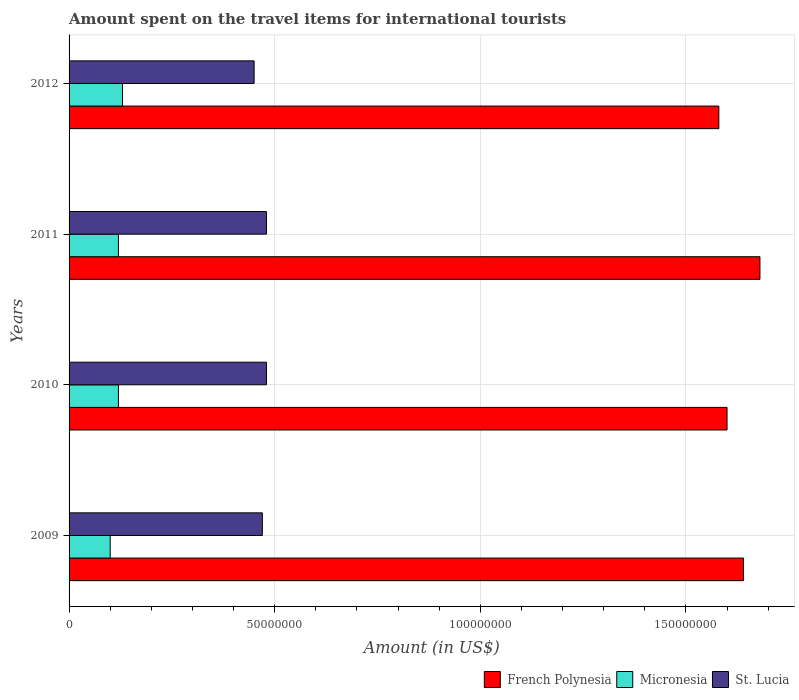How many bars are there on the 4th tick from the top?
Your answer should be compact. 3. In how many cases, is the number of bars for a given year not equal to the number of legend labels?
Offer a terse response. 0. What is the amount spent on the travel items for international tourists in St. Lucia in 2010?
Your response must be concise. 4.80e+07. Across all years, what is the maximum amount spent on the travel items for international tourists in Micronesia?
Give a very brief answer. 1.30e+07. Across all years, what is the minimum amount spent on the travel items for international tourists in St. Lucia?
Keep it short and to the point. 4.50e+07. In which year was the amount spent on the travel items for international tourists in French Polynesia minimum?
Keep it short and to the point. 2012. What is the total amount spent on the travel items for international tourists in St. Lucia in the graph?
Offer a very short reply. 1.88e+08. What is the difference between the amount spent on the travel items for international tourists in St. Lucia in 2010 and that in 2011?
Your answer should be very brief. 0. What is the difference between the amount spent on the travel items for international tourists in French Polynesia in 2010 and the amount spent on the travel items for international tourists in Micronesia in 2009?
Provide a succinct answer. 1.50e+08. What is the average amount spent on the travel items for international tourists in Micronesia per year?
Offer a terse response. 1.18e+07. In the year 2011, what is the difference between the amount spent on the travel items for international tourists in French Polynesia and amount spent on the travel items for international tourists in Micronesia?
Provide a short and direct response. 1.56e+08. What is the ratio of the amount spent on the travel items for international tourists in French Polynesia in 2010 to that in 2012?
Offer a terse response. 1.01. Is the sum of the amount spent on the travel items for international tourists in St. Lucia in 2010 and 2011 greater than the maximum amount spent on the travel items for international tourists in French Polynesia across all years?
Offer a terse response. No. What does the 2nd bar from the top in 2012 represents?
Give a very brief answer. Micronesia. What does the 1st bar from the bottom in 2009 represents?
Ensure brevity in your answer.  French Polynesia. Is it the case that in every year, the sum of the amount spent on the travel items for international tourists in St. Lucia and amount spent on the travel items for international tourists in Micronesia is greater than the amount spent on the travel items for international tourists in French Polynesia?
Make the answer very short. No. How many bars are there?
Keep it short and to the point. 12. Are all the bars in the graph horizontal?
Give a very brief answer. Yes. How many years are there in the graph?
Offer a very short reply. 4. What is the difference between two consecutive major ticks on the X-axis?
Provide a succinct answer. 5.00e+07. Are the values on the major ticks of X-axis written in scientific E-notation?
Your answer should be compact. No. Where does the legend appear in the graph?
Ensure brevity in your answer.  Bottom right. How are the legend labels stacked?
Keep it short and to the point. Horizontal. What is the title of the graph?
Give a very brief answer. Amount spent on the travel items for international tourists. Does "Lower middle income" appear as one of the legend labels in the graph?
Keep it short and to the point. No. What is the label or title of the Y-axis?
Ensure brevity in your answer.  Years. What is the Amount (in US$) in French Polynesia in 2009?
Provide a short and direct response. 1.64e+08. What is the Amount (in US$) in Micronesia in 2009?
Your answer should be compact. 1.00e+07. What is the Amount (in US$) of St. Lucia in 2009?
Make the answer very short. 4.70e+07. What is the Amount (in US$) in French Polynesia in 2010?
Your answer should be very brief. 1.60e+08. What is the Amount (in US$) in Micronesia in 2010?
Keep it short and to the point. 1.20e+07. What is the Amount (in US$) in St. Lucia in 2010?
Provide a short and direct response. 4.80e+07. What is the Amount (in US$) in French Polynesia in 2011?
Ensure brevity in your answer.  1.68e+08. What is the Amount (in US$) of Micronesia in 2011?
Offer a terse response. 1.20e+07. What is the Amount (in US$) of St. Lucia in 2011?
Offer a very short reply. 4.80e+07. What is the Amount (in US$) of French Polynesia in 2012?
Give a very brief answer. 1.58e+08. What is the Amount (in US$) of Micronesia in 2012?
Offer a terse response. 1.30e+07. What is the Amount (in US$) in St. Lucia in 2012?
Your answer should be very brief. 4.50e+07. Across all years, what is the maximum Amount (in US$) in French Polynesia?
Give a very brief answer. 1.68e+08. Across all years, what is the maximum Amount (in US$) of Micronesia?
Give a very brief answer. 1.30e+07. Across all years, what is the maximum Amount (in US$) of St. Lucia?
Provide a succinct answer. 4.80e+07. Across all years, what is the minimum Amount (in US$) in French Polynesia?
Make the answer very short. 1.58e+08. Across all years, what is the minimum Amount (in US$) in St. Lucia?
Give a very brief answer. 4.50e+07. What is the total Amount (in US$) in French Polynesia in the graph?
Make the answer very short. 6.50e+08. What is the total Amount (in US$) of Micronesia in the graph?
Your answer should be compact. 4.70e+07. What is the total Amount (in US$) in St. Lucia in the graph?
Keep it short and to the point. 1.88e+08. What is the difference between the Amount (in US$) of French Polynesia in 2009 and that in 2010?
Your answer should be compact. 4.00e+06. What is the difference between the Amount (in US$) in Micronesia in 2009 and that in 2010?
Make the answer very short. -2.00e+06. What is the difference between the Amount (in US$) in St. Lucia in 2009 and that in 2011?
Offer a terse response. -1.00e+06. What is the difference between the Amount (in US$) of Micronesia in 2009 and that in 2012?
Make the answer very short. -3.00e+06. What is the difference between the Amount (in US$) of St. Lucia in 2009 and that in 2012?
Keep it short and to the point. 2.00e+06. What is the difference between the Amount (in US$) of French Polynesia in 2010 and that in 2011?
Make the answer very short. -8.00e+06. What is the difference between the Amount (in US$) of Micronesia in 2010 and that in 2011?
Ensure brevity in your answer.  0. What is the difference between the Amount (in US$) of French Polynesia in 2010 and that in 2012?
Your response must be concise. 2.00e+06. What is the difference between the Amount (in US$) of French Polynesia in 2011 and that in 2012?
Provide a short and direct response. 1.00e+07. What is the difference between the Amount (in US$) in French Polynesia in 2009 and the Amount (in US$) in Micronesia in 2010?
Keep it short and to the point. 1.52e+08. What is the difference between the Amount (in US$) of French Polynesia in 2009 and the Amount (in US$) of St. Lucia in 2010?
Keep it short and to the point. 1.16e+08. What is the difference between the Amount (in US$) of Micronesia in 2009 and the Amount (in US$) of St. Lucia in 2010?
Provide a succinct answer. -3.80e+07. What is the difference between the Amount (in US$) of French Polynesia in 2009 and the Amount (in US$) of Micronesia in 2011?
Offer a very short reply. 1.52e+08. What is the difference between the Amount (in US$) in French Polynesia in 2009 and the Amount (in US$) in St. Lucia in 2011?
Your answer should be compact. 1.16e+08. What is the difference between the Amount (in US$) of Micronesia in 2009 and the Amount (in US$) of St. Lucia in 2011?
Make the answer very short. -3.80e+07. What is the difference between the Amount (in US$) in French Polynesia in 2009 and the Amount (in US$) in Micronesia in 2012?
Your answer should be compact. 1.51e+08. What is the difference between the Amount (in US$) in French Polynesia in 2009 and the Amount (in US$) in St. Lucia in 2012?
Your answer should be very brief. 1.19e+08. What is the difference between the Amount (in US$) in Micronesia in 2009 and the Amount (in US$) in St. Lucia in 2012?
Your response must be concise. -3.50e+07. What is the difference between the Amount (in US$) of French Polynesia in 2010 and the Amount (in US$) of Micronesia in 2011?
Your response must be concise. 1.48e+08. What is the difference between the Amount (in US$) of French Polynesia in 2010 and the Amount (in US$) of St. Lucia in 2011?
Your answer should be very brief. 1.12e+08. What is the difference between the Amount (in US$) in Micronesia in 2010 and the Amount (in US$) in St. Lucia in 2011?
Provide a succinct answer. -3.60e+07. What is the difference between the Amount (in US$) in French Polynesia in 2010 and the Amount (in US$) in Micronesia in 2012?
Provide a short and direct response. 1.47e+08. What is the difference between the Amount (in US$) in French Polynesia in 2010 and the Amount (in US$) in St. Lucia in 2012?
Provide a succinct answer. 1.15e+08. What is the difference between the Amount (in US$) in Micronesia in 2010 and the Amount (in US$) in St. Lucia in 2012?
Your answer should be compact. -3.30e+07. What is the difference between the Amount (in US$) of French Polynesia in 2011 and the Amount (in US$) of Micronesia in 2012?
Give a very brief answer. 1.55e+08. What is the difference between the Amount (in US$) in French Polynesia in 2011 and the Amount (in US$) in St. Lucia in 2012?
Ensure brevity in your answer.  1.23e+08. What is the difference between the Amount (in US$) of Micronesia in 2011 and the Amount (in US$) of St. Lucia in 2012?
Offer a very short reply. -3.30e+07. What is the average Amount (in US$) of French Polynesia per year?
Offer a terse response. 1.62e+08. What is the average Amount (in US$) in Micronesia per year?
Provide a succinct answer. 1.18e+07. What is the average Amount (in US$) of St. Lucia per year?
Make the answer very short. 4.70e+07. In the year 2009, what is the difference between the Amount (in US$) of French Polynesia and Amount (in US$) of Micronesia?
Offer a terse response. 1.54e+08. In the year 2009, what is the difference between the Amount (in US$) in French Polynesia and Amount (in US$) in St. Lucia?
Provide a short and direct response. 1.17e+08. In the year 2009, what is the difference between the Amount (in US$) of Micronesia and Amount (in US$) of St. Lucia?
Offer a very short reply. -3.70e+07. In the year 2010, what is the difference between the Amount (in US$) of French Polynesia and Amount (in US$) of Micronesia?
Your response must be concise. 1.48e+08. In the year 2010, what is the difference between the Amount (in US$) in French Polynesia and Amount (in US$) in St. Lucia?
Offer a terse response. 1.12e+08. In the year 2010, what is the difference between the Amount (in US$) in Micronesia and Amount (in US$) in St. Lucia?
Ensure brevity in your answer.  -3.60e+07. In the year 2011, what is the difference between the Amount (in US$) in French Polynesia and Amount (in US$) in Micronesia?
Keep it short and to the point. 1.56e+08. In the year 2011, what is the difference between the Amount (in US$) in French Polynesia and Amount (in US$) in St. Lucia?
Offer a terse response. 1.20e+08. In the year 2011, what is the difference between the Amount (in US$) of Micronesia and Amount (in US$) of St. Lucia?
Keep it short and to the point. -3.60e+07. In the year 2012, what is the difference between the Amount (in US$) in French Polynesia and Amount (in US$) in Micronesia?
Give a very brief answer. 1.45e+08. In the year 2012, what is the difference between the Amount (in US$) in French Polynesia and Amount (in US$) in St. Lucia?
Offer a terse response. 1.13e+08. In the year 2012, what is the difference between the Amount (in US$) in Micronesia and Amount (in US$) in St. Lucia?
Provide a succinct answer. -3.20e+07. What is the ratio of the Amount (in US$) of French Polynesia in 2009 to that in 2010?
Provide a succinct answer. 1.02. What is the ratio of the Amount (in US$) in Micronesia in 2009 to that in 2010?
Give a very brief answer. 0.83. What is the ratio of the Amount (in US$) in St. Lucia in 2009 to that in 2010?
Your answer should be very brief. 0.98. What is the ratio of the Amount (in US$) in French Polynesia in 2009 to that in 2011?
Offer a very short reply. 0.98. What is the ratio of the Amount (in US$) in Micronesia in 2009 to that in 2011?
Offer a very short reply. 0.83. What is the ratio of the Amount (in US$) of St. Lucia in 2009 to that in 2011?
Give a very brief answer. 0.98. What is the ratio of the Amount (in US$) in French Polynesia in 2009 to that in 2012?
Your answer should be compact. 1.04. What is the ratio of the Amount (in US$) in Micronesia in 2009 to that in 2012?
Make the answer very short. 0.77. What is the ratio of the Amount (in US$) in St. Lucia in 2009 to that in 2012?
Provide a short and direct response. 1.04. What is the ratio of the Amount (in US$) in French Polynesia in 2010 to that in 2011?
Keep it short and to the point. 0.95. What is the ratio of the Amount (in US$) of French Polynesia in 2010 to that in 2012?
Provide a short and direct response. 1.01. What is the ratio of the Amount (in US$) in St. Lucia in 2010 to that in 2012?
Keep it short and to the point. 1.07. What is the ratio of the Amount (in US$) of French Polynesia in 2011 to that in 2012?
Make the answer very short. 1.06. What is the ratio of the Amount (in US$) of St. Lucia in 2011 to that in 2012?
Your response must be concise. 1.07. What is the difference between the highest and the second highest Amount (in US$) of St. Lucia?
Ensure brevity in your answer.  0. What is the difference between the highest and the lowest Amount (in US$) of French Polynesia?
Offer a very short reply. 1.00e+07. What is the difference between the highest and the lowest Amount (in US$) of Micronesia?
Your response must be concise. 3.00e+06. 